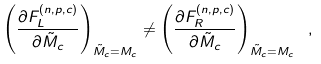Convert formula to latex. <formula><loc_0><loc_0><loc_500><loc_500>\left ( \frac { \partial F _ { L } ^ { ( n , p , c ) } } { \partial \tilde { M } _ { c } } \right ) _ { \tilde { M } _ { c } = M _ { c } } \ne \left ( \frac { \partial F _ { R } ^ { ( n , p , c ) } } { \partial \tilde { M } _ { c } } \right ) _ { \tilde { M } _ { c } = M _ { c } } \ ,</formula> 